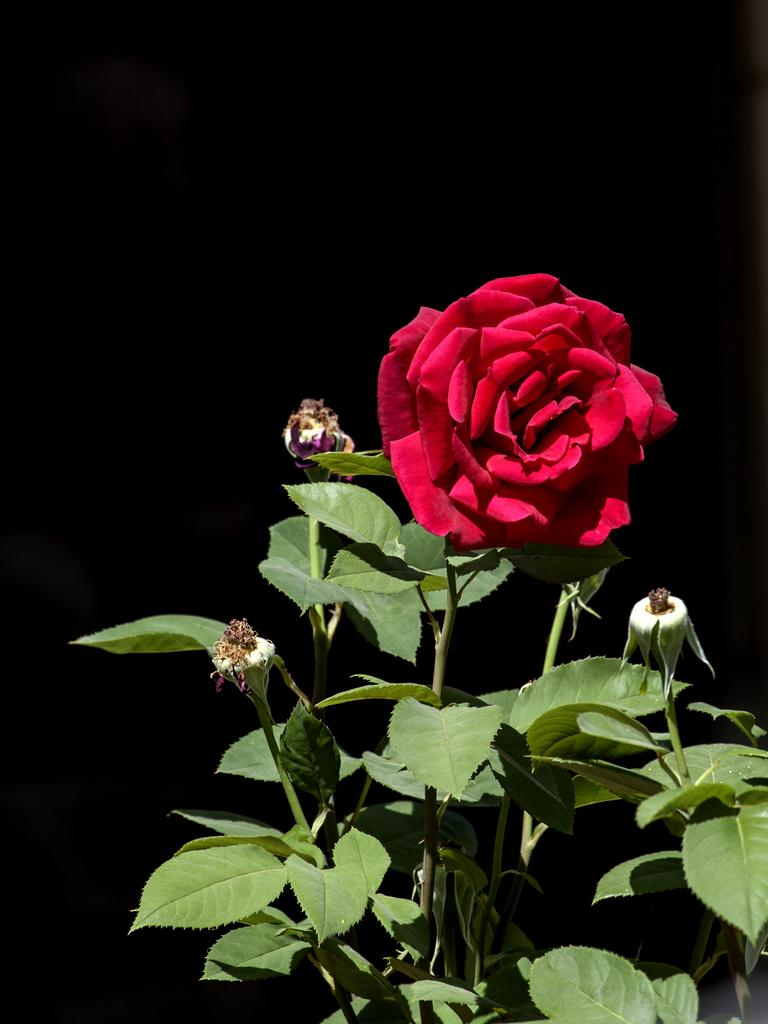What type of flower is in the image? There is a red color rose flower in the image. What else can be seen in the image besides the flower? There are leaves in the image. What is the color of the background in the image? The background of the image is dark. Can you tell me how much honey the goose is carrying in the image? There is no goose or honey present in the image; it features a red color rose flower and leaves. Is there an actor in the image? There is no actor present in the image; it features a red color rose flower and leaves. 